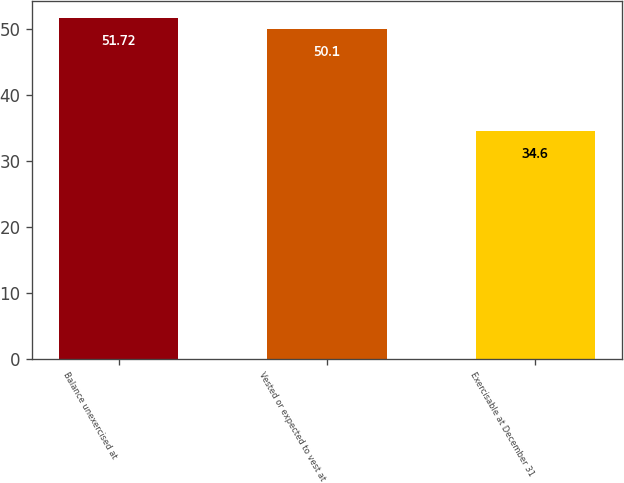<chart> <loc_0><loc_0><loc_500><loc_500><bar_chart><fcel>Balance unexercised at<fcel>Vested or expected to vest at<fcel>Exercisable at December 31<nl><fcel>51.72<fcel>50.1<fcel>34.6<nl></chart> 